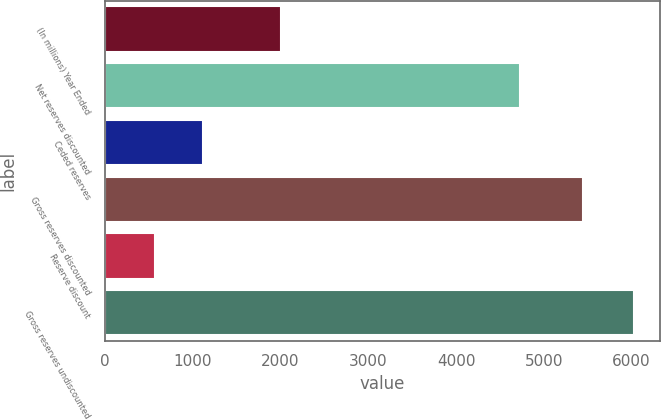Convert chart. <chart><loc_0><loc_0><loc_500><loc_500><bar_chart><fcel>(In millions) Year Ended<fcel>Net reserves discounted<fcel>Ceded reserves<fcel>Gross reserves discounted<fcel>Reserve discount<fcel>Gross reserves undiscounted<nl><fcel>2004<fcel>4723<fcel>1118<fcel>5450<fcel>573<fcel>6023<nl></chart> 